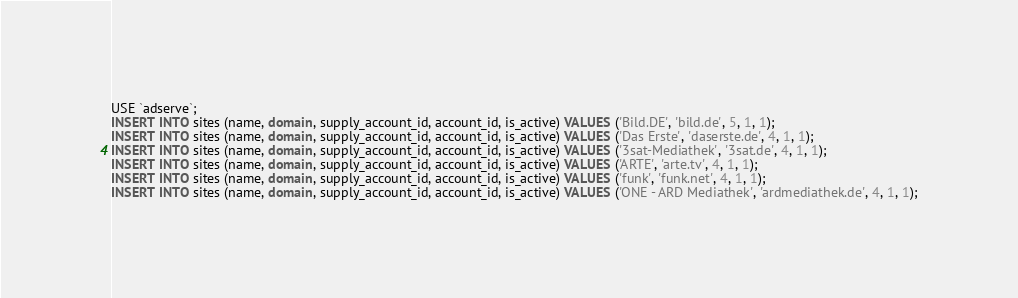Convert code to text. <code><loc_0><loc_0><loc_500><loc_500><_SQL_>USE `adserve`;
INSERT INTO sites (name, domain, supply_account_id, account_id, is_active) VALUES ('Bild.DE', 'bild.de', 5, 1, 1);
INSERT INTO sites (name, domain, supply_account_id, account_id, is_active) VALUES ('Das Erste', 'daserste.de', 4, 1, 1);
INSERT INTO sites (name, domain, supply_account_id, account_id, is_active) VALUES ('3sat-Mediathek', '3sat.de', 4, 1, 1);
INSERT INTO sites (name, domain, supply_account_id, account_id, is_active) VALUES ('ARTE', 'arte.tv', 4, 1, 1);
INSERT INTO sites (name, domain, supply_account_id, account_id, is_active) VALUES ('funk', 'funk.net', 4, 1, 1);
INSERT INTO sites (name, domain, supply_account_id, account_id, is_active) VALUES ('ONE - ARD Mediathek', 'ardmediathek.de', 4, 1, 1);
</code> 